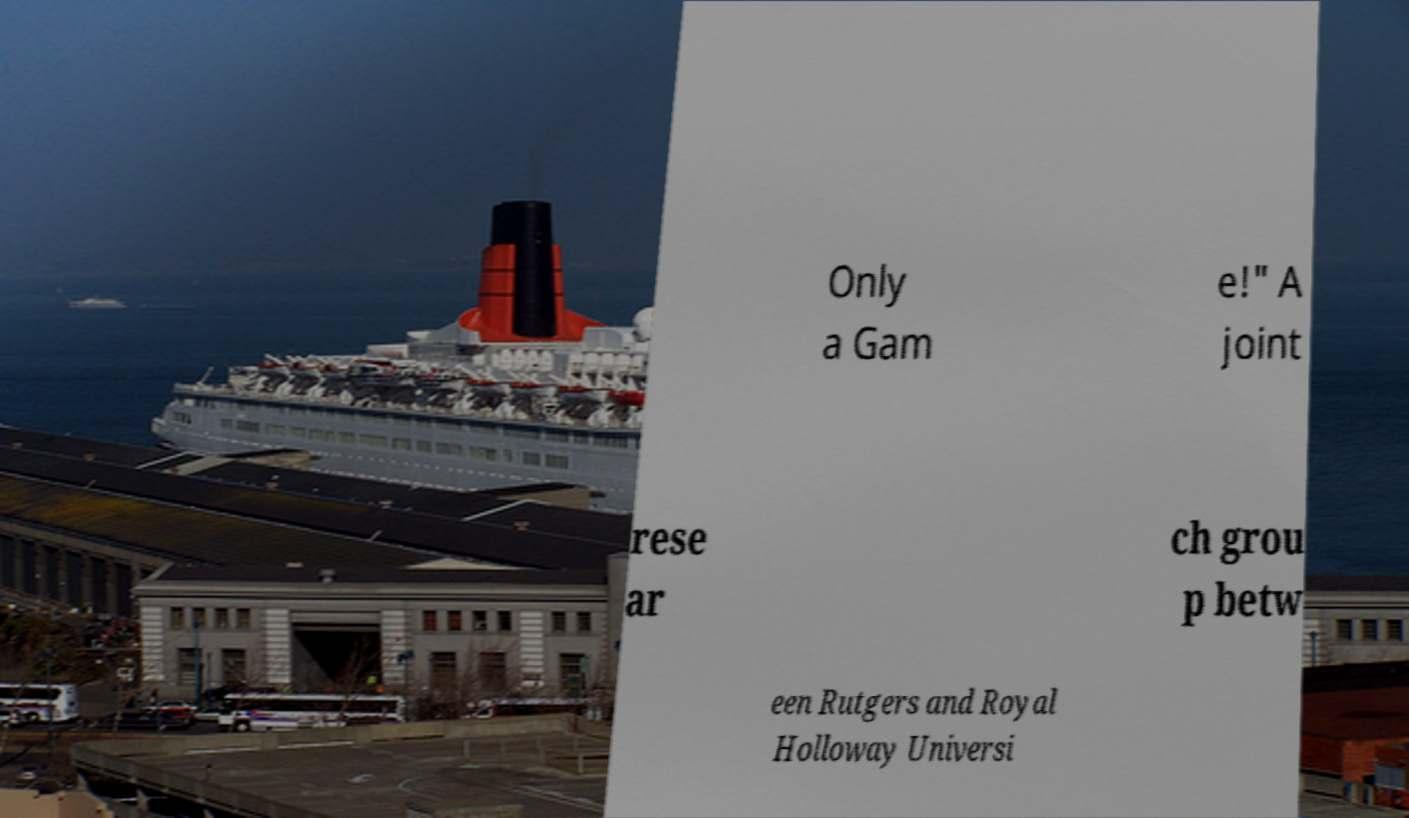For documentation purposes, I need the text within this image transcribed. Could you provide that? Only a Gam e!" A joint rese ar ch grou p betw een Rutgers and Royal Holloway Universi 